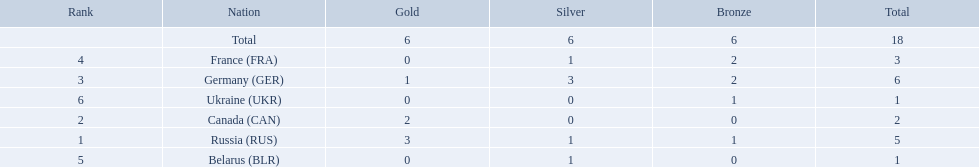Which countries competed in the 1995 biathlon? Russia (RUS), Canada (CAN), Germany (GER), France (FRA), Belarus (BLR), Ukraine (UKR). Parse the full table. {'header': ['Rank', 'Nation', 'Gold', 'Silver', 'Bronze', 'Total'], 'rows': [['', 'Total', '6', '6', '6', '18'], ['4', 'France\xa0(FRA)', '0', '1', '2', '3'], ['3', 'Germany\xa0(GER)', '1', '3', '2', '6'], ['6', 'Ukraine\xa0(UKR)', '0', '0', '1', '1'], ['2', 'Canada\xa0(CAN)', '2', '0', '0', '2'], ['1', 'Russia\xa0(RUS)', '3', '1', '1', '5'], ['5', 'Belarus\xa0(BLR)', '0', '1', '0', '1']]} How many medals in total did they win? 5, 2, 6, 3, 1, 1. And which country had the most? Germany (GER). Which countries received gold medals? Russia (RUS), Canada (CAN), Germany (GER). Of these countries, which did not receive a silver medal? Canada (CAN). 